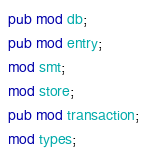Convert code to text. <code><loc_0><loc_0><loc_500><loc_500><_Rust_>pub mod db;
pub mod entry;
mod smt;
mod store;
pub mod transaction;
mod types;
</code> 